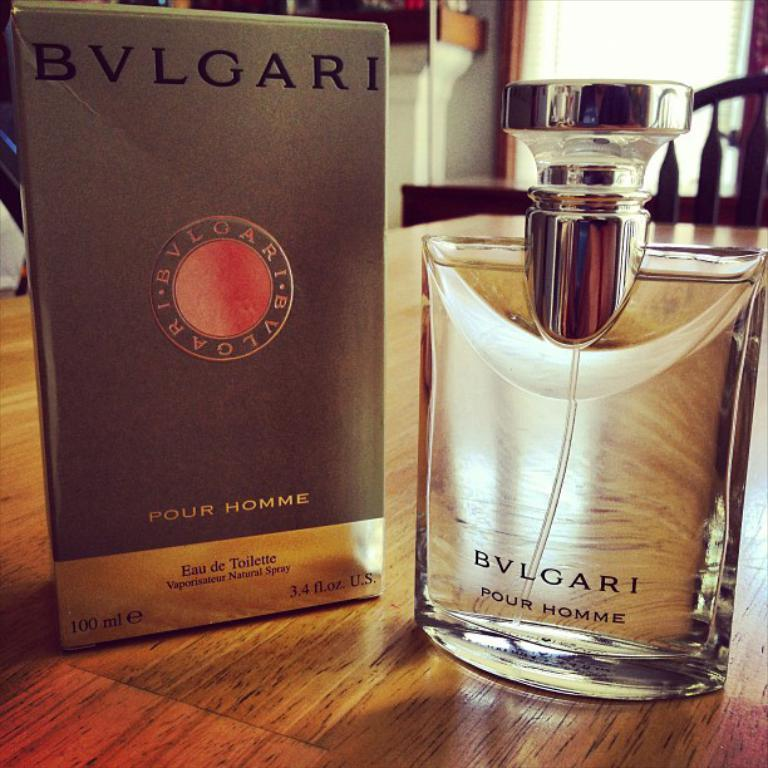Provide a one-sentence caption for the provided image. A bottle of Bvlgari perfume sits next to the box that it came in. 